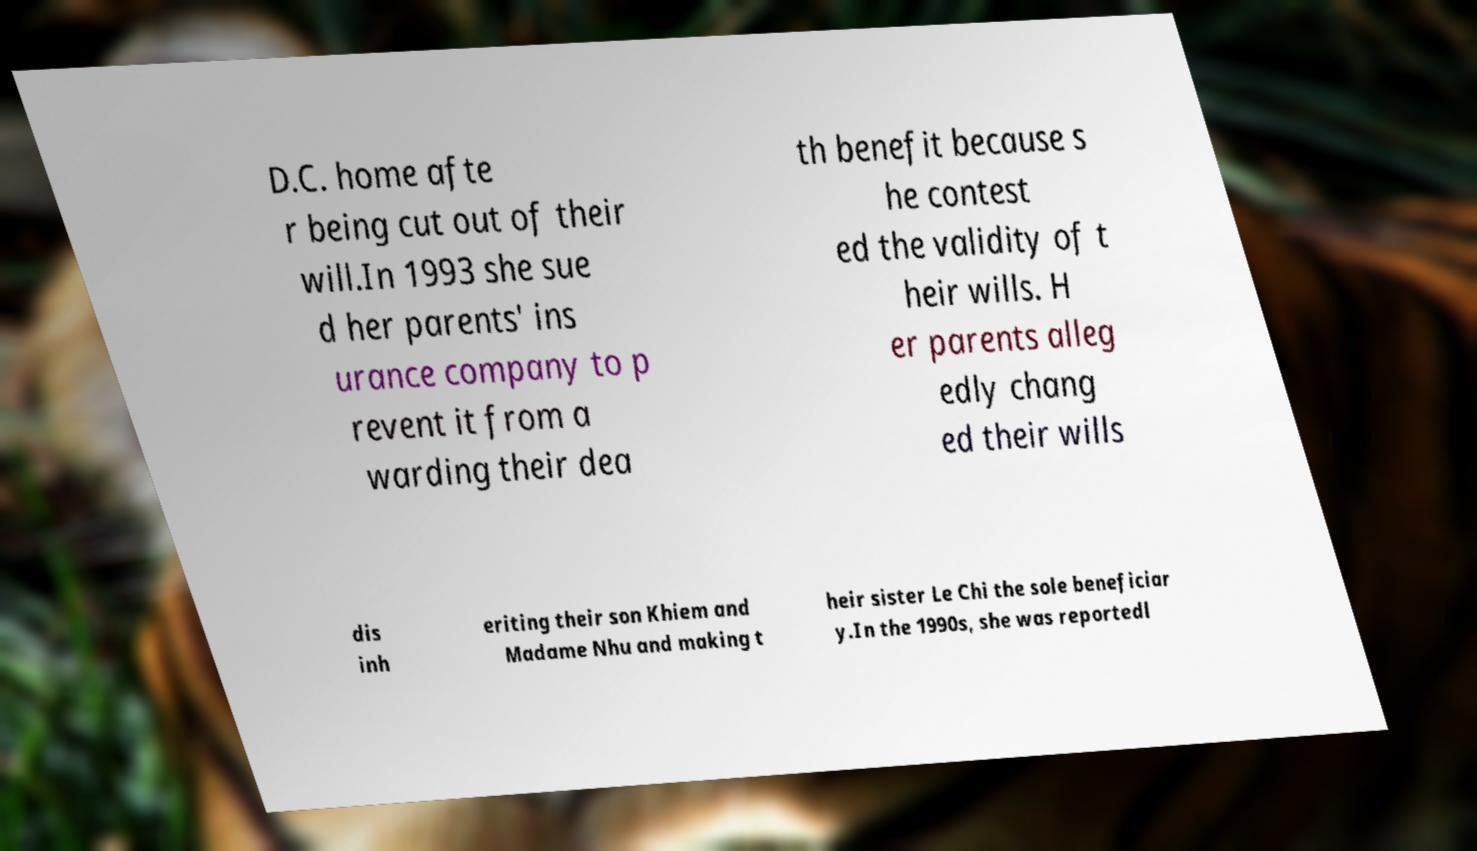I need the written content from this picture converted into text. Can you do that? D.C. home afte r being cut out of their will.In 1993 she sue d her parents' ins urance company to p revent it from a warding their dea th benefit because s he contest ed the validity of t heir wills. H er parents alleg edly chang ed their wills dis inh eriting their son Khiem and Madame Nhu and making t heir sister Le Chi the sole beneficiar y.In the 1990s, she was reportedl 